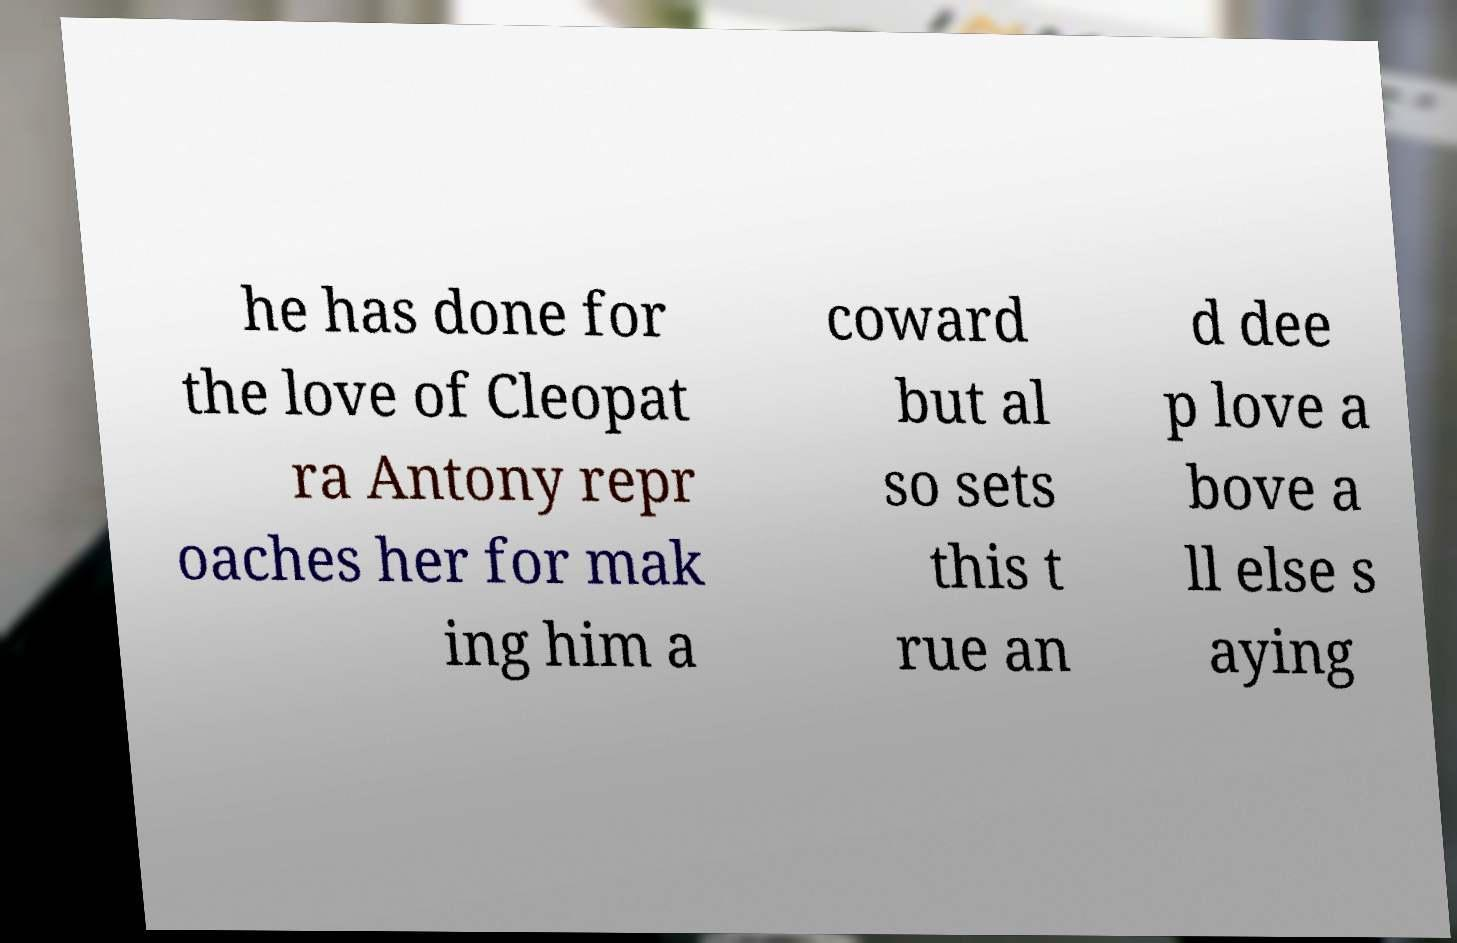Could you extract and type out the text from this image? he has done for the love of Cleopat ra Antony repr oaches her for mak ing him a coward but al so sets this t rue an d dee p love a bove a ll else s aying 